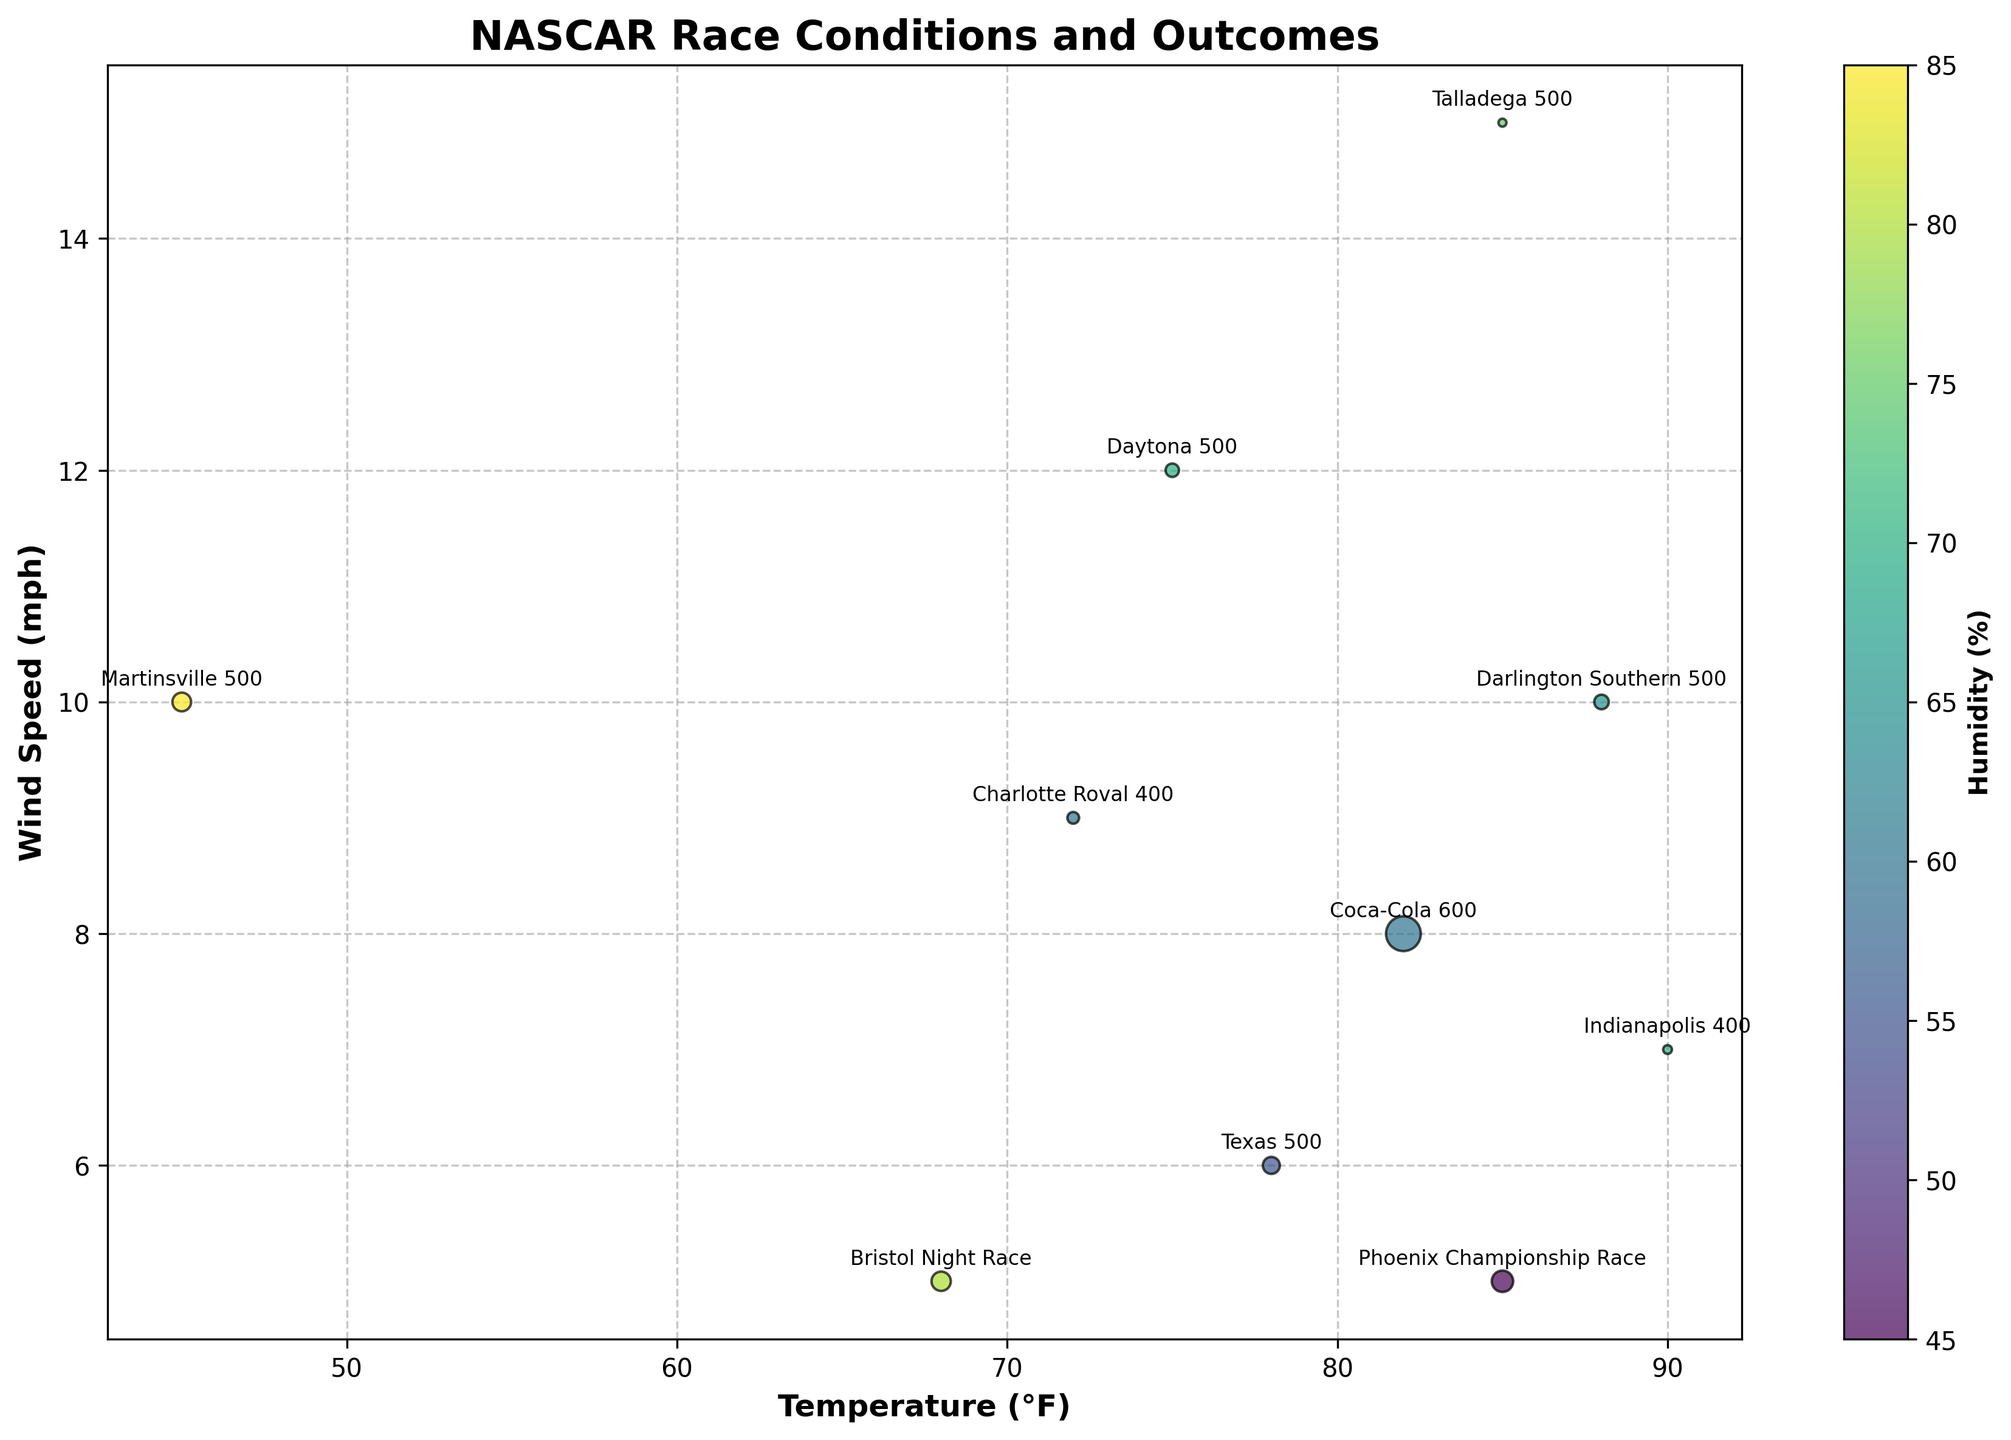How many events are represented by data points in the figure? By counting the number of distinct bubbles or data points in the figure, we can determine the total number of events represented. Each event in the data corresponds to a unique bubble.
Answer: 10 Which event had the highest wind speed, and what was the wind speed? Look for the bubble positioned furthest to the right along the x-axis labeled 'Wind Speed (mph)'. Identifying the event name associated with this bubble reveals the highest wind speed.
Answer: Talladega 500, 15 mph What is the common range of temperatures in these major NASCAR events? Examine the spread of bubbles along the x-axis labeled 'Temperature (°F)'. Identify the minimum and maximum temperature values to determine the range.
Answer: 45°F to 90°F How does humidity appear to affect the size of the bubbles? Each bubble's size is proportional to the laps led by the winner and its color indicates humidity levels. Observing the relationship between bubble colors and sizes reveals if higher humidity correlates with larger or smaller bubbles.
Answer: Higher humidity often corresponds to larger bubbles Which event had the most laps led by the winner, and what was that number? Identify the largest bubble in the figure (since bubble size represents laps led by the winner). Look for the label associated with this bubble to find the event and number of laps.
Answer: Coca-Cola 600, 377 laps Is there a noticeable pattern in wind speed concerning temperature? Observe the distribution of bubbles along the y-axis (wind speed) for various x-axis (temperature) values. Look for trends or clusters that indicate a relationship.
Answer: Higher temperatures tend to have higher wind speeds Which two events had the same wind speed of 10 mph, and how do their temperatures and laps led by winners compare? Locate the bubbles at the 10 mph mark on the y-axis. Identify the events by their labels and compare their x-axis positions (temperature) and bubble sizes (laps led).
Answer: Martinsville 500 (45°F, 109 laps) and Darlington Southern 500 (88°F, 66 laps) How does precipitation seem to impact the finish position of the pole sitter? Each bubble can be examined to see if there's any observable relationship between bubble placement (events) with different precipitation values and the designated finish position of the pole sitter (given in the data).
Answer: Events with precipitation have varied pole sitter positions, indicating no clear pattern Which event appears to have taken place under the lowest humidity, and what was the laps led by the winner for that event? Inspect the bubbles to find the one with the lightest color, as this indicates the lowest humidity. Use the event label and corresponding bubble size to determine the laps led by the winner.
Answer: Phoenix Championship Race, 143 laps What do the bubbles' colors represent, and how does this help in interpreting the environmental conditions? The color of the bubbles represents humidity levels (%). By interpreting the color spectrum (from lighter to darker shades), we can deduce the relative humidity of each event, aiding in understanding how this variable might influence the races.
Answer: Humidity (%) 